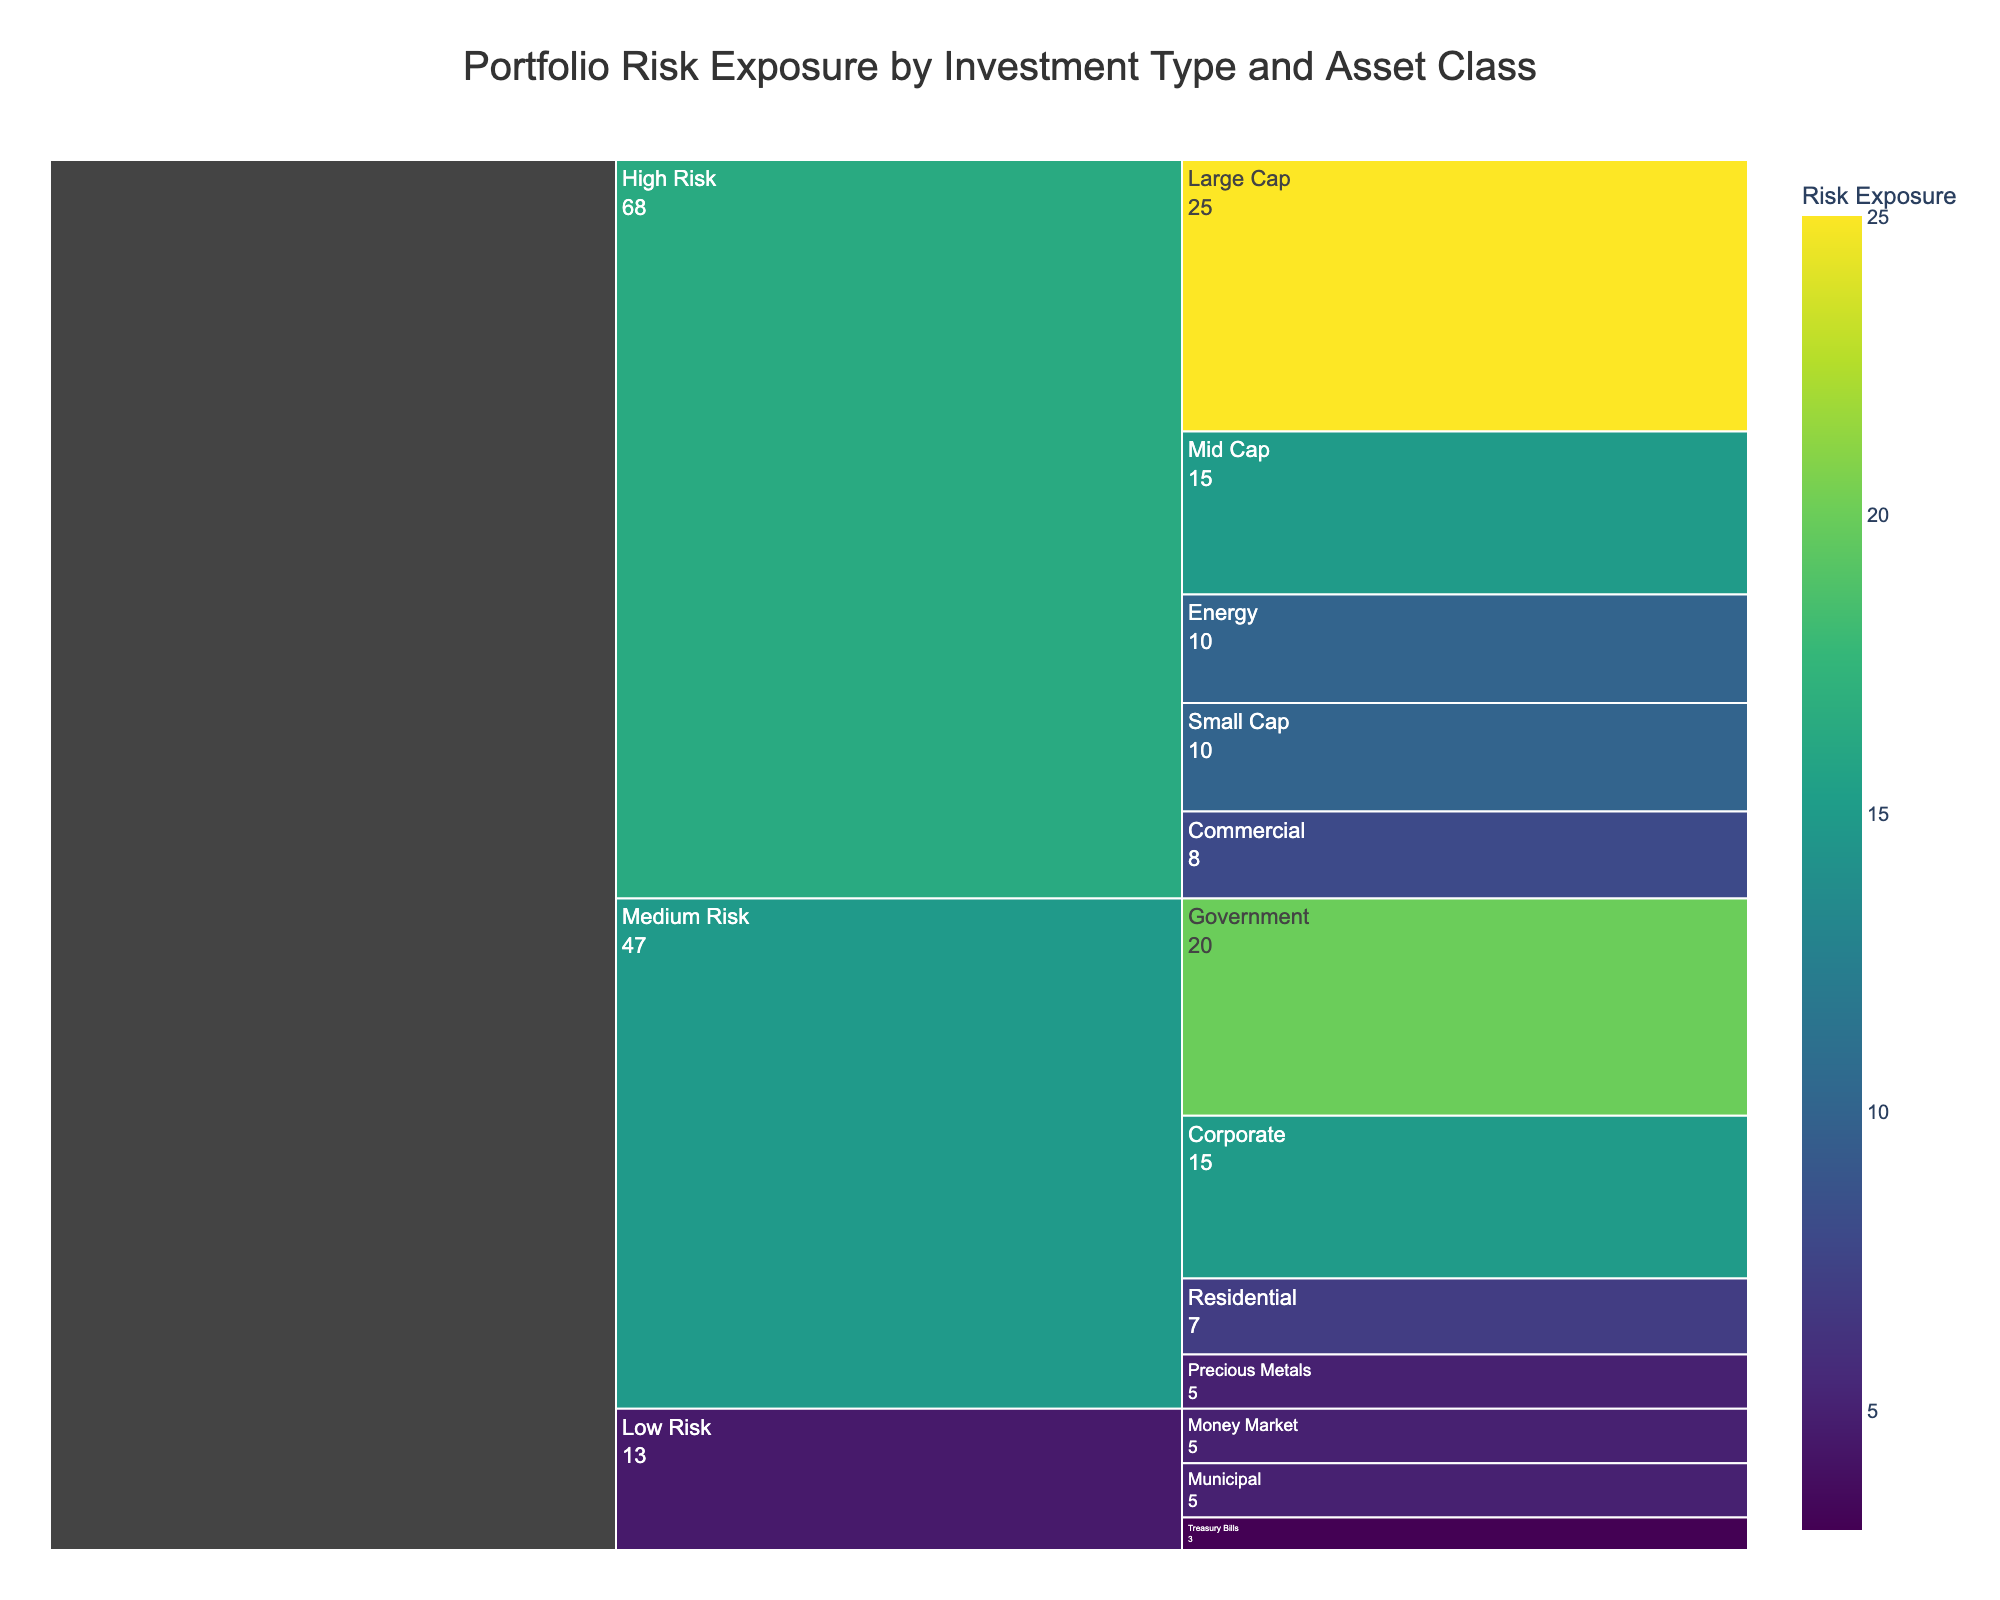What is the title of the icicle chart? The title is displayed at the top center of the chart, indicating the main focus.
Answer: Portfolio Risk Exposure by Investment Type and Asset Class Which investment type has the highest overall risk exposure? By observing the largest segment in the chart, the investment type with the highest overall risk exposure can be identified.
Answer: Stocks What is the total risk exposure for high-risk investments within the Stocks category? The risk exposures of all high-risk asset classes within the Stocks category need to be summed. Specifically, add the values for Large Cap (25), Mid Cap (15), and Small Cap (10).
Answer: 50 Which asset class within the Bonds category is considered to have medium risk? The Bonds category is segmented into risk categories, and the medium risk segment needs to be identified.
Answer: Government and Corporate Compare the risk exposure of Commercial Real Estate and Energy Commodities. Which one is higher? Check the values corresponding to Commercial Real Estate (8) and Energy Commodities (10) in the high-risk segment of Real Estate and Commodities respectively.
Answer: Energy Commodities What is the combined risk exposure for all low-risk investments? Sum the risk exposures for all asset classes under the low-risk category: Municipal (5), Money Market (5), and Treasury Bills (3).
Answer: 13 How does the risk exposure of Residential Real Estate compare to Precious Metals in the Commodities category? Compare the values associated with Residential Real Estate (7) in the medium-risk Real Estate category and Precious Metals (5) in the medium-risk Commodities category.
Answer: Residential Real Estate is higher What is the average risk exposure for all asset classes within the Bonds category? Calculate the average by summing up the risk exposures of Government (20), Corporate (15), and Municipal (5), then dividing by the number of asset classes (3).
Answer: 13.33 Identify the asset class with the lowest risk exposure. Look for the segment with the smallest risk exposure value in the chart, irrespective of category.
Answer: Treasury Bills Which investment type has no high-risk asset classes? Identify which categories only contain medium and low-risk segments.
Answer: Cash Equivalents 